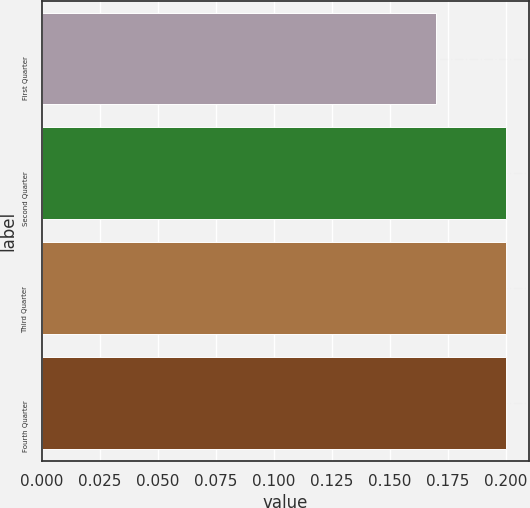Convert chart. <chart><loc_0><loc_0><loc_500><loc_500><bar_chart><fcel>First Quarter<fcel>Second Quarter<fcel>Third Quarter<fcel>Fourth Quarter<nl><fcel>0.17<fcel>0.2<fcel>0.2<fcel>0.2<nl></chart> 